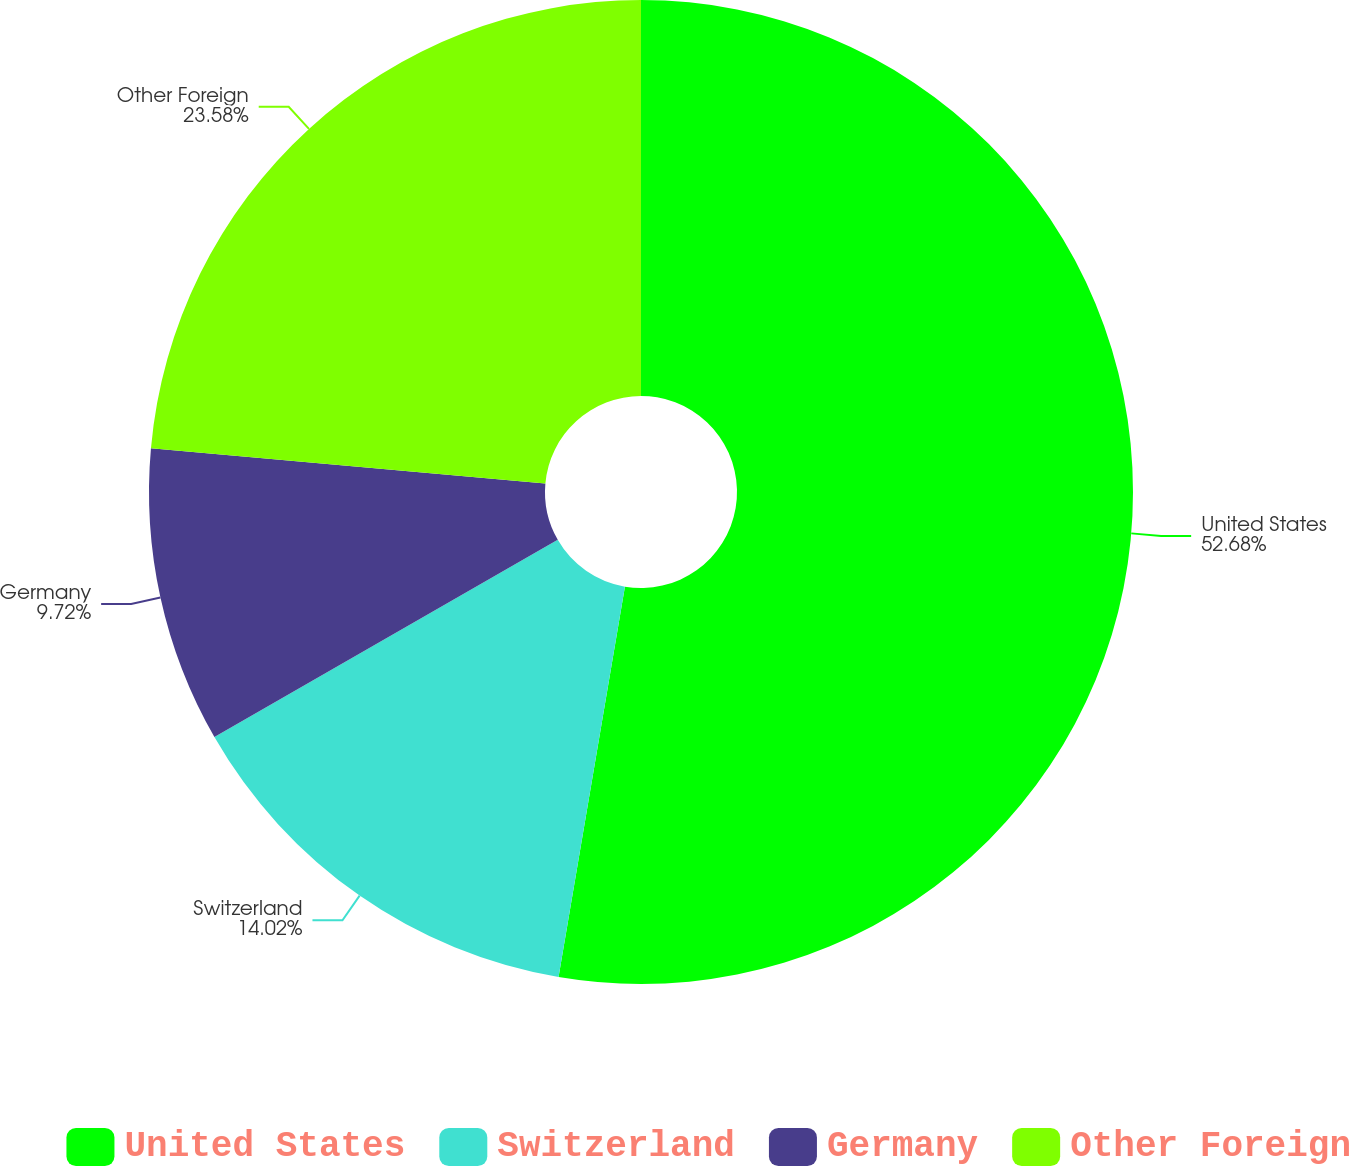<chart> <loc_0><loc_0><loc_500><loc_500><pie_chart><fcel>United States<fcel>Switzerland<fcel>Germany<fcel>Other Foreign<nl><fcel>52.68%<fcel>14.02%<fcel>9.72%<fcel>23.58%<nl></chart> 